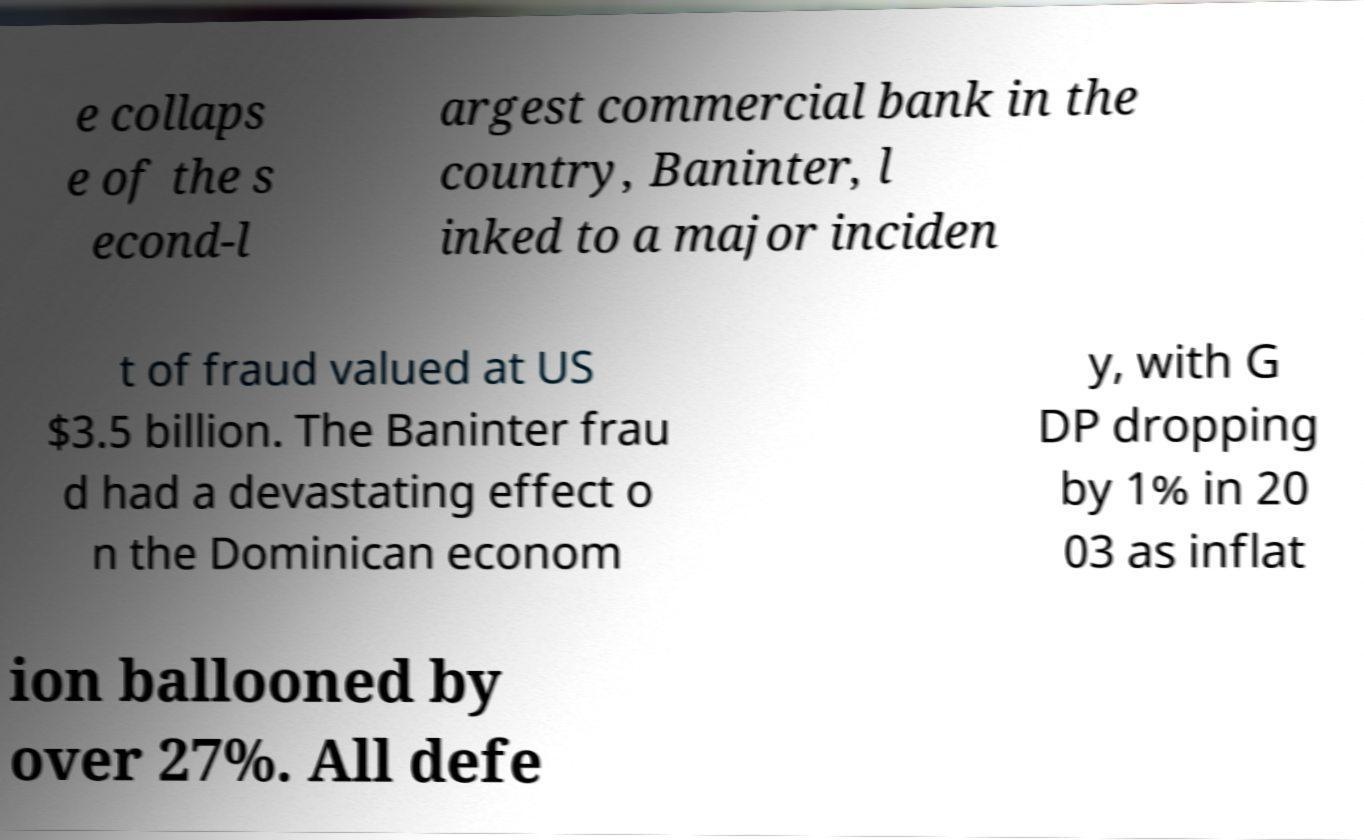Please read and relay the text visible in this image. What does it say? e collaps e of the s econd-l argest commercial bank in the country, Baninter, l inked to a major inciden t of fraud valued at US $3.5 billion. The Baninter frau d had a devastating effect o n the Dominican econom y, with G DP dropping by 1% in 20 03 as inflat ion ballooned by over 27%. All defe 